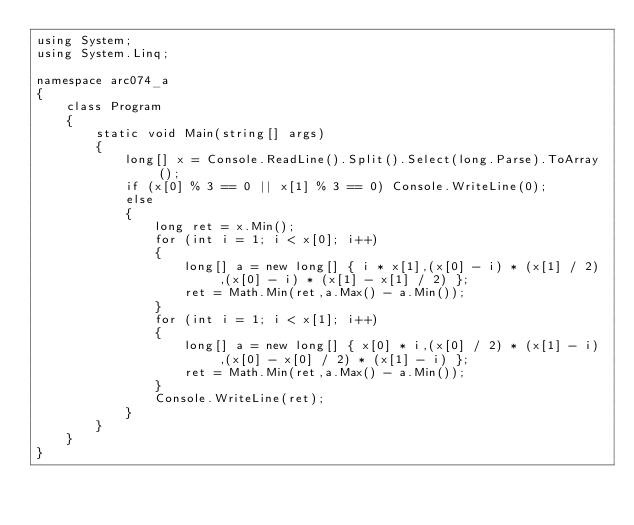<code> <loc_0><loc_0><loc_500><loc_500><_C#_>using System;
using System.Linq;

namespace arc074_a
{
    class Program
    {
        static void Main(string[] args)
        {
            long[] x = Console.ReadLine().Split().Select(long.Parse).ToArray();
            if (x[0] % 3 == 0 || x[1] % 3 == 0) Console.WriteLine(0);
            else
            {
                long ret = x.Min();
                for (int i = 1; i < x[0]; i++)
                {
                    long[] a = new long[] { i * x[1],(x[0] - i) * (x[1] / 2),(x[0] - i) * (x[1] - x[1] / 2) };
                    ret = Math.Min(ret,a.Max() - a.Min());
                }
                for (int i = 1; i < x[1]; i++)
                {
                    long[] a = new long[] { x[0] * i,(x[0] / 2) * (x[1] - i),(x[0] - x[0] / 2) * (x[1] - i) };
                    ret = Math.Min(ret,a.Max() - a.Min());
                }
                Console.WriteLine(ret);
            }
        }
    }
}</code> 